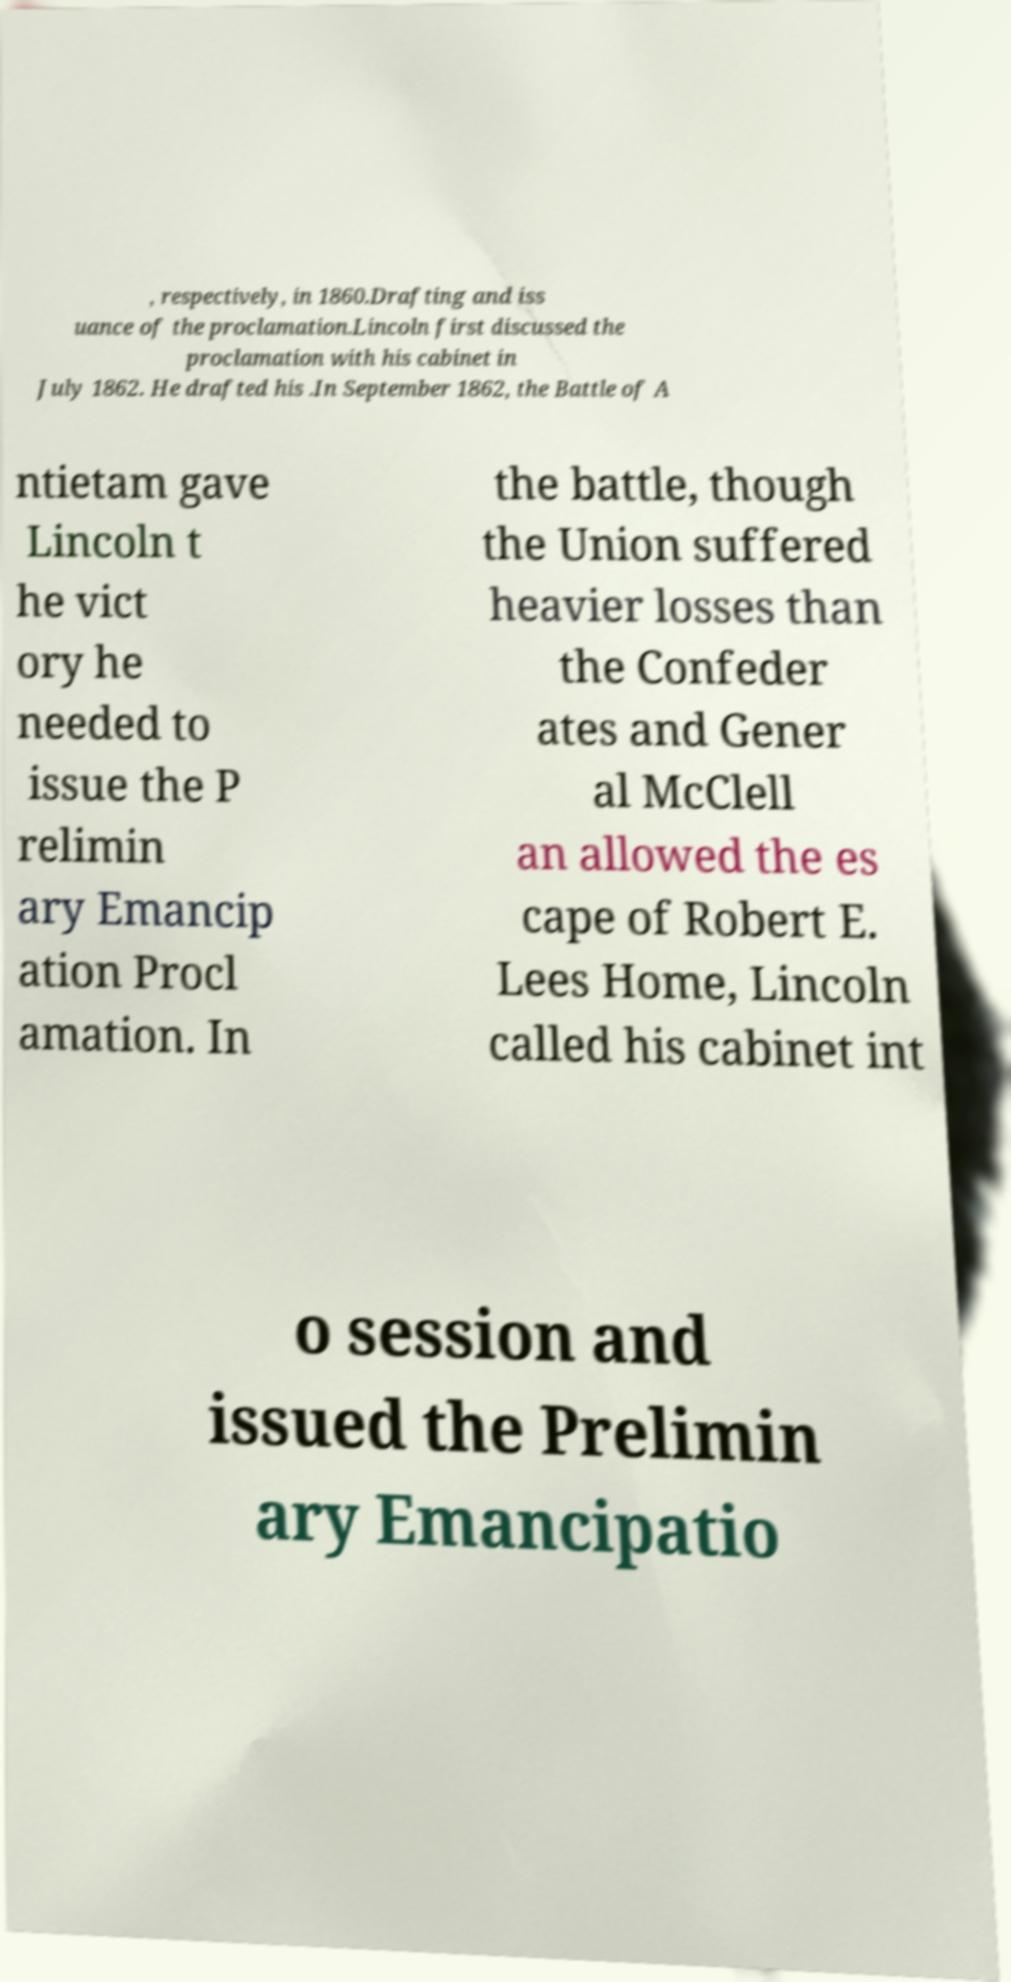There's text embedded in this image that I need extracted. Can you transcribe it verbatim? , respectively, in 1860.Drafting and iss uance of the proclamation.Lincoln first discussed the proclamation with his cabinet in July 1862. He drafted his .In September 1862, the Battle of A ntietam gave Lincoln t he vict ory he needed to issue the P relimin ary Emancip ation Procl amation. In the battle, though the Union suffered heavier losses than the Confeder ates and Gener al McClell an allowed the es cape of Robert E. Lees Home, Lincoln called his cabinet int o session and issued the Prelimin ary Emancipatio 